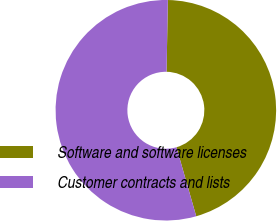Convert chart to OTSL. <chart><loc_0><loc_0><loc_500><loc_500><pie_chart><fcel>Software and software licenses<fcel>Customer contracts and lists<nl><fcel>45.27%<fcel>54.73%<nl></chart> 